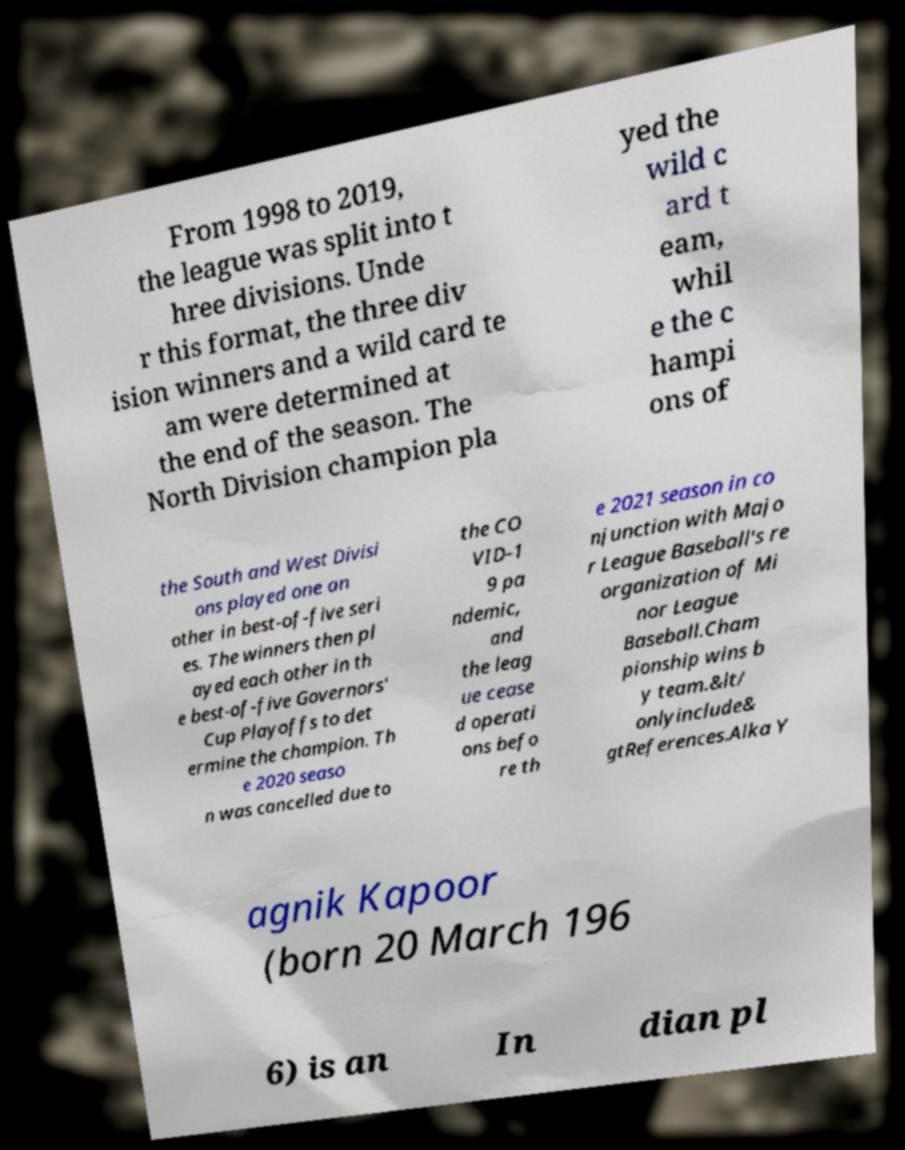Can you read and provide the text displayed in the image?This photo seems to have some interesting text. Can you extract and type it out for me? From 1998 to 2019, the league was split into t hree divisions. Unde r this format, the three div ision winners and a wild card te am were determined at the end of the season. The North Division champion pla yed the wild c ard t eam, whil e the c hampi ons of the South and West Divisi ons played one an other in best-of-five seri es. The winners then pl ayed each other in th e best-of-five Governors' Cup Playoffs to det ermine the champion. Th e 2020 seaso n was cancelled due to the CO VID-1 9 pa ndemic, and the leag ue cease d operati ons befo re th e 2021 season in co njunction with Majo r League Baseball's re organization of Mi nor League Baseball.Cham pionship wins b y team.&lt/ onlyinclude& gtReferences.Alka Y agnik Kapoor (born 20 March 196 6) is an In dian pl 